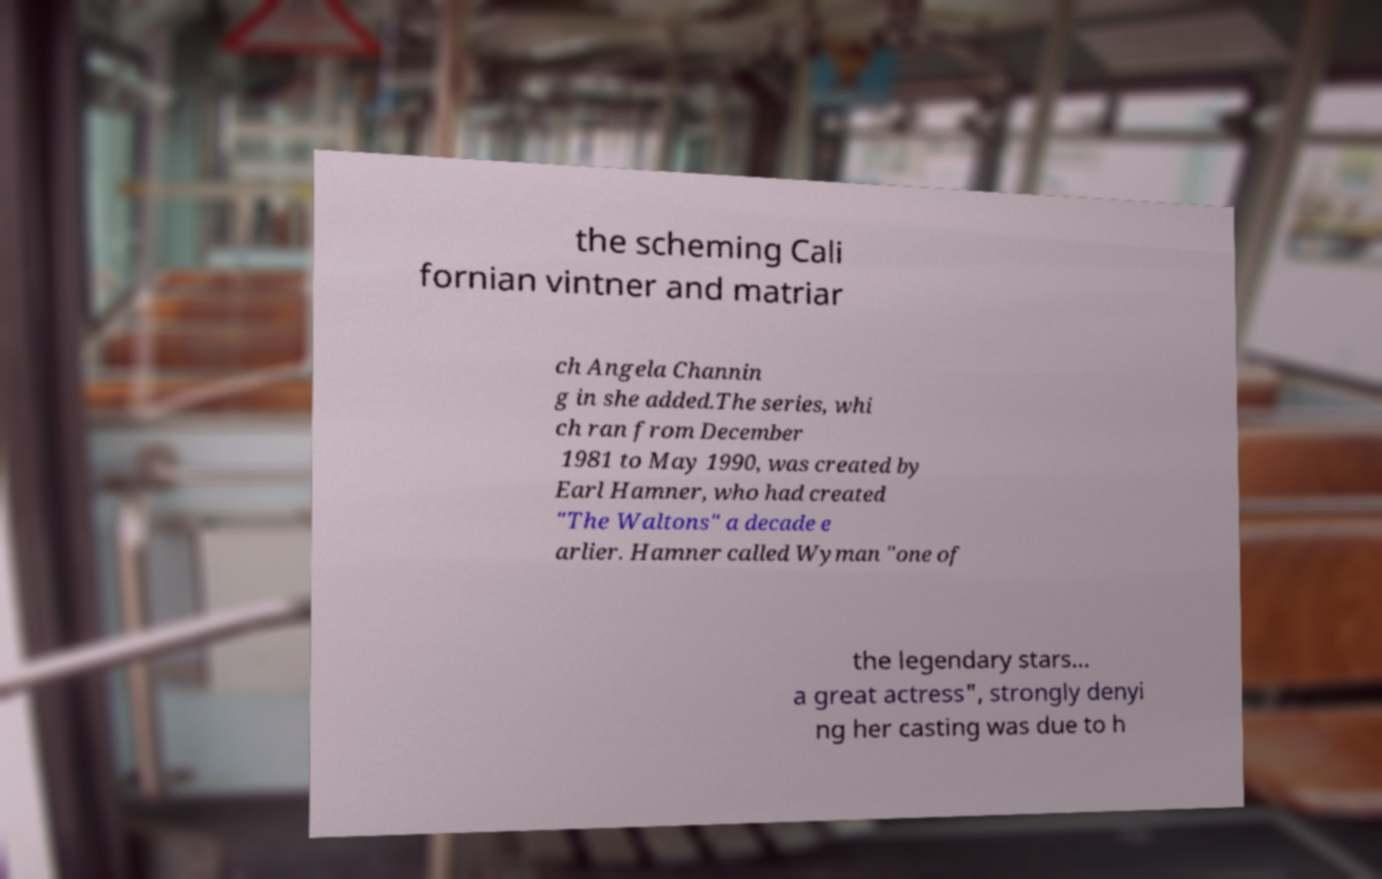There's text embedded in this image that I need extracted. Can you transcribe it verbatim? the scheming Cali fornian vintner and matriar ch Angela Channin g in she added.The series, whi ch ran from December 1981 to May 1990, was created by Earl Hamner, who had created "The Waltons" a decade e arlier. Hamner called Wyman "one of the legendary stars... a great actress", strongly denyi ng her casting was due to h 